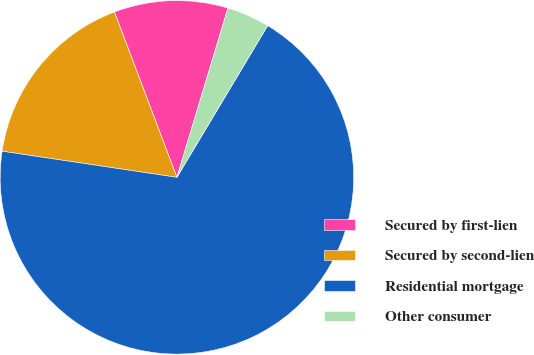Convert chart. <chart><loc_0><loc_0><loc_500><loc_500><pie_chart><fcel>Secured by first-lien<fcel>Secured by second-lien<fcel>Residential mortgage<fcel>Other consumer<nl><fcel>10.41%<fcel>16.89%<fcel>68.78%<fcel>3.92%<nl></chart> 